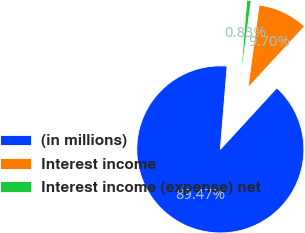<chart> <loc_0><loc_0><loc_500><loc_500><pie_chart><fcel>(in millions)<fcel>Interest income<fcel>Interest income (expense) net<nl><fcel>89.47%<fcel>9.7%<fcel>0.83%<nl></chart> 